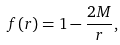<formula> <loc_0><loc_0><loc_500><loc_500>f ( r ) = 1 - \frac { 2 M } { r } ,</formula> 